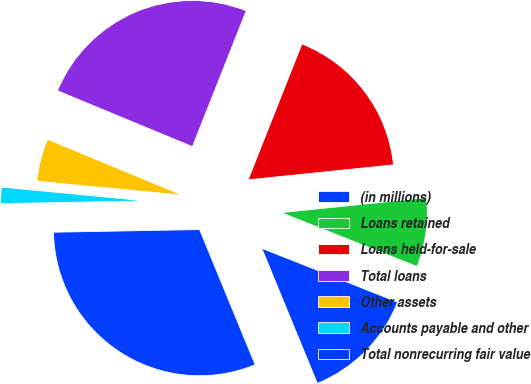Convert chart to OTSL. <chart><loc_0><loc_0><loc_500><loc_500><pie_chart><fcel>(in millions)<fcel>Loans retained<fcel>Loans held-for-sale<fcel>Total loans<fcel>Other assets<fcel>Accounts payable and other<fcel>Total nonrecurring fair value<nl><fcel>12.78%<fcel>7.64%<fcel>17.37%<fcel>24.75%<fcel>4.73%<fcel>1.81%<fcel>30.92%<nl></chart> 